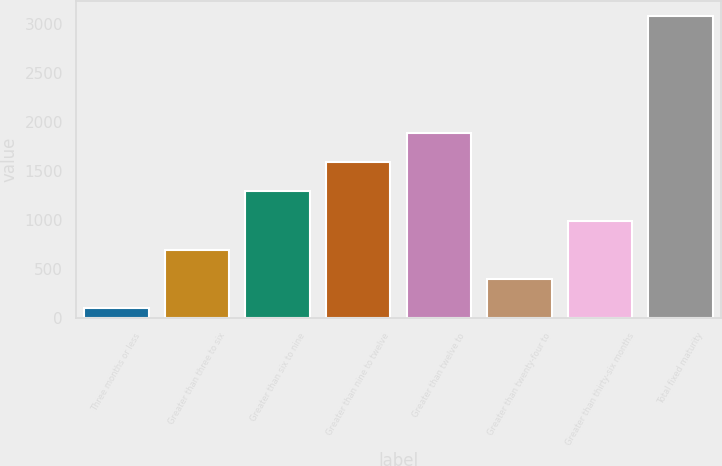Convert chart. <chart><loc_0><loc_0><loc_500><loc_500><bar_chart><fcel>Three months or less<fcel>Greater than three to six<fcel>Greater than six to nine<fcel>Greater than nine to twelve<fcel>Greater than twelve to<fcel>Greater than twenty-four to<fcel>Greater than thirty-six months<fcel>Total fixed maturity<nl><fcel>99.5<fcel>697.44<fcel>1295.38<fcel>1594.35<fcel>1893.32<fcel>398.47<fcel>996.41<fcel>3089.2<nl></chart> 